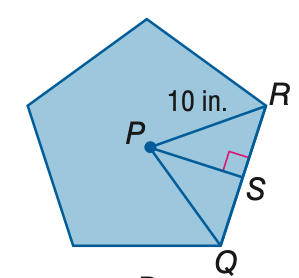Answer the mathemtical geometry problem and directly provide the correct option letter.
Question: Find the area of the regular polygon. Round to the nearest tenth.
Choices: A: 47.6 B: 118.9 C: 237.8 D: 475.6 C 